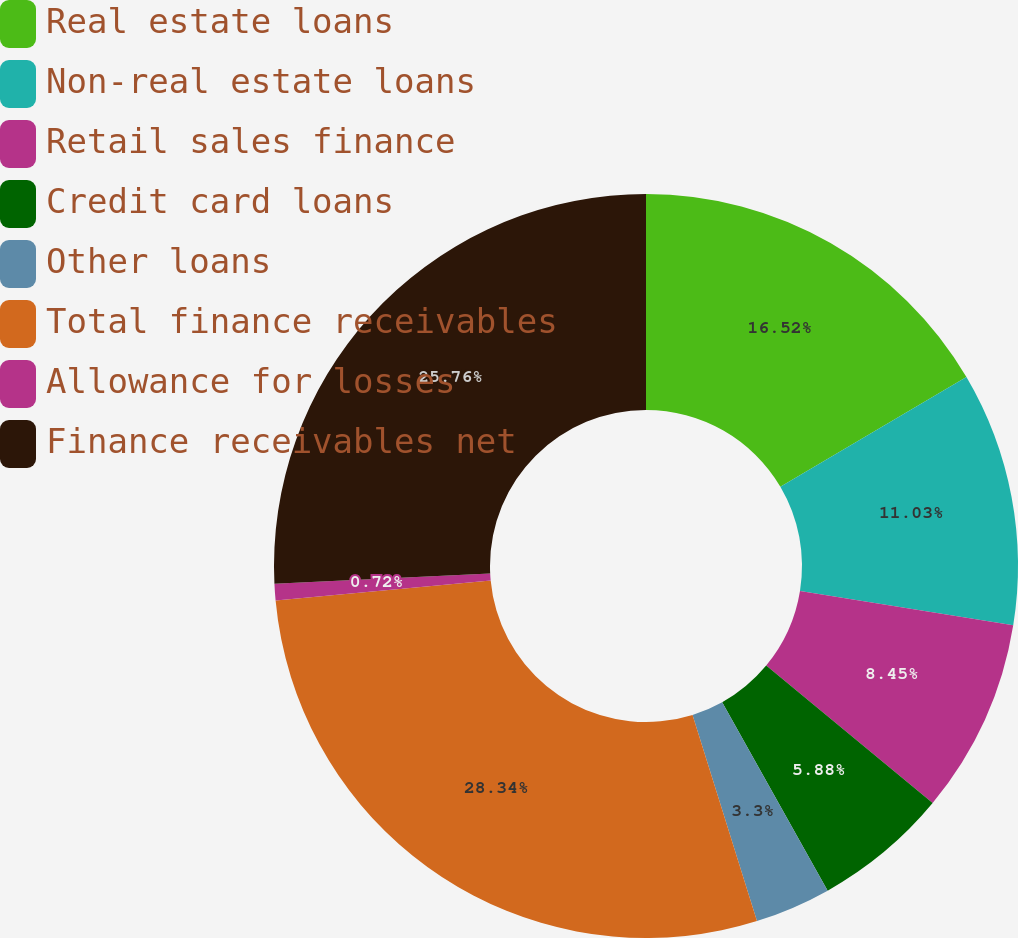Convert chart. <chart><loc_0><loc_0><loc_500><loc_500><pie_chart><fcel>Real estate loans<fcel>Non-real estate loans<fcel>Retail sales finance<fcel>Credit card loans<fcel>Other loans<fcel>Total finance receivables<fcel>Allowance for losses<fcel>Finance receivables net<nl><fcel>16.52%<fcel>11.03%<fcel>8.45%<fcel>5.88%<fcel>3.3%<fcel>28.34%<fcel>0.72%<fcel>25.76%<nl></chart> 